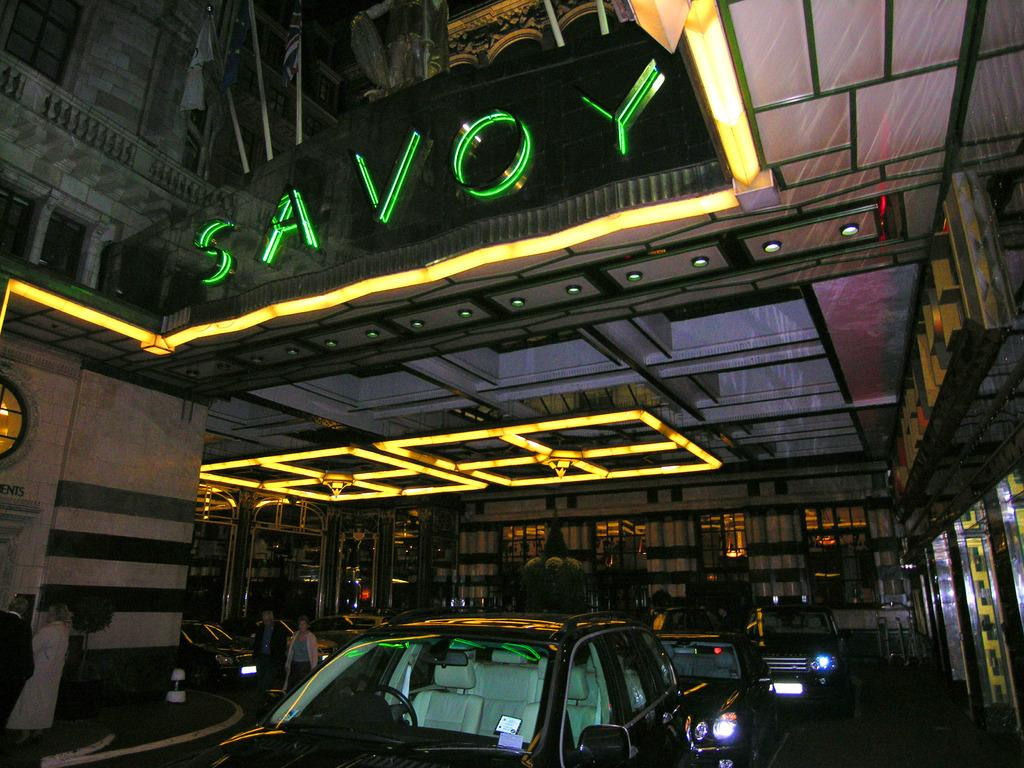<image>
Give a short and clear explanation of the subsequent image. green and yellow lights with the green having an O and Y prsent 